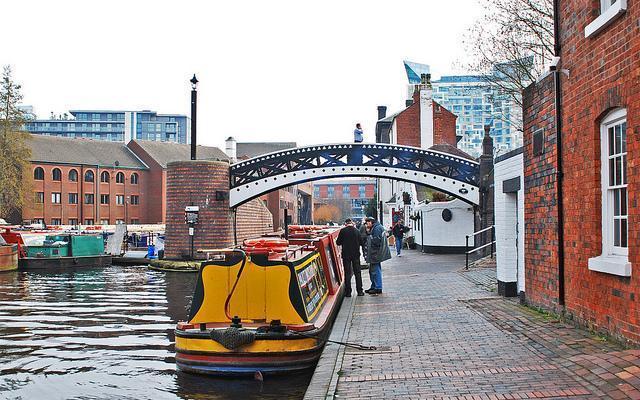How many boats are in the picture?
Give a very brief answer. 2. 